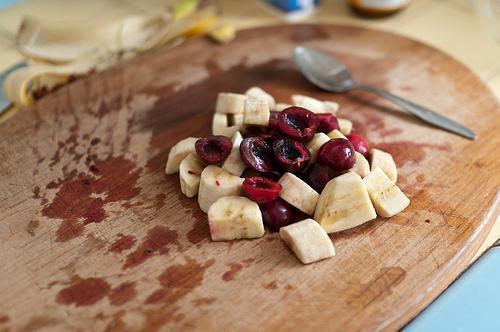How many different kinds of fruit are in the photo?
Give a very brief answer. 2. 